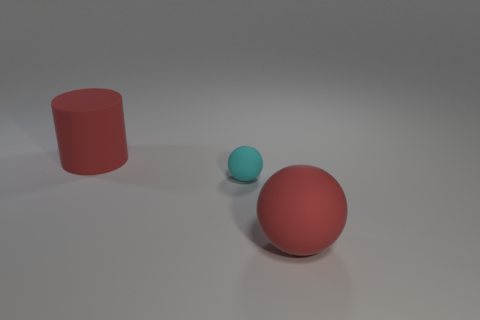Add 1 small purple metal objects. How many objects exist? 4 Subtract all balls. How many objects are left? 1 Subtract 1 red cylinders. How many objects are left? 2 Subtract all brown matte cylinders. Subtract all big balls. How many objects are left? 2 Add 2 small spheres. How many small spheres are left? 3 Add 1 large red matte things. How many large red matte things exist? 3 